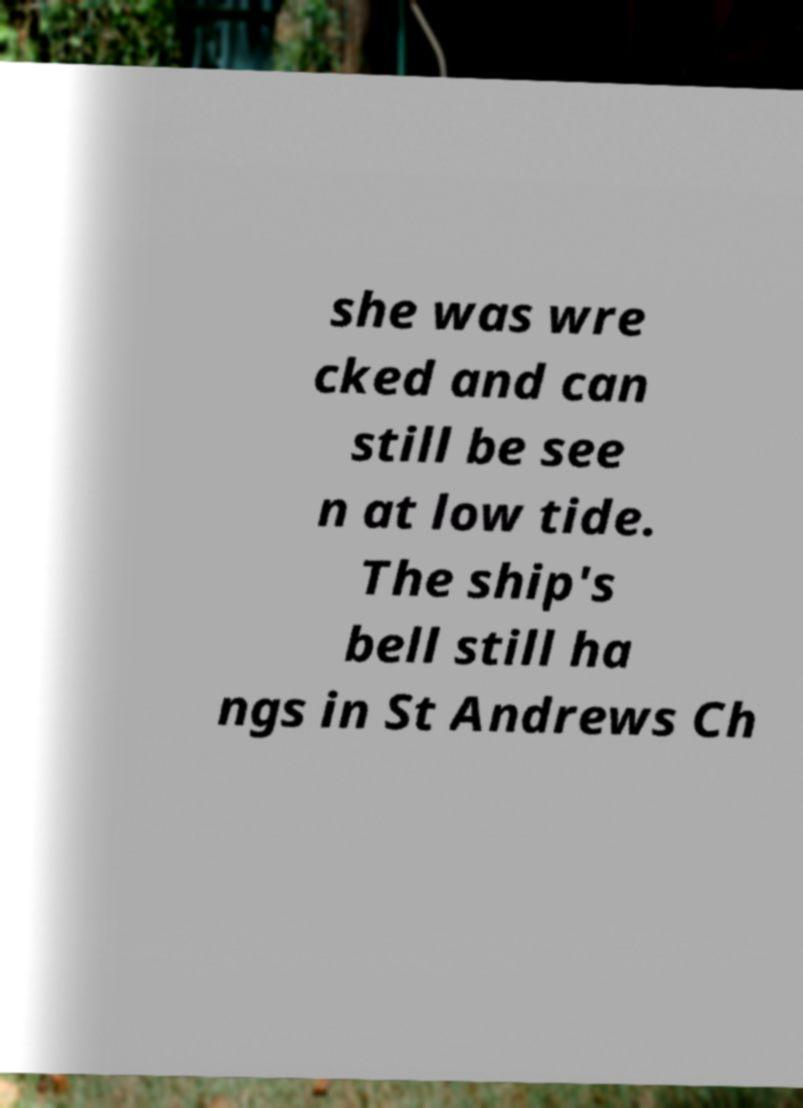What messages or text are displayed in this image? I need them in a readable, typed format. she was wre cked and can still be see n at low tide. The ship's bell still ha ngs in St Andrews Ch 